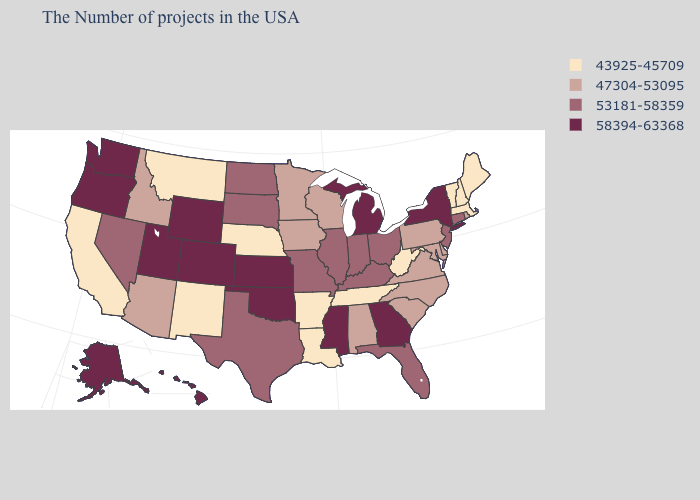Which states have the highest value in the USA?
Give a very brief answer. New York, Georgia, Michigan, Mississippi, Kansas, Oklahoma, Wyoming, Colorado, Utah, Washington, Oregon, Alaska, Hawaii. Which states have the highest value in the USA?
Give a very brief answer. New York, Georgia, Michigan, Mississippi, Kansas, Oklahoma, Wyoming, Colorado, Utah, Washington, Oregon, Alaska, Hawaii. Which states hav the highest value in the MidWest?
Answer briefly. Michigan, Kansas. Which states have the highest value in the USA?
Concise answer only. New York, Georgia, Michigan, Mississippi, Kansas, Oklahoma, Wyoming, Colorado, Utah, Washington, Oregon, Alaska, Hawaii. What is the lowest value in the USA?
Write a very short answer. 43925-45709. Does Washington have the highest value in the USA?
Short answer required. Yes. What is the value of Missouri?
Short answer required. 53181-58359. Does Louisiana have the lowest value in the USA?
Quick response, please. Yes. Name the states that have a value in the range 58394-63368?
Answer briefly. New York, Georgia, Michigan, Mississippi, Kansas, Oklahoma, Wyoming, Colorado, Utah, Washington, Oregon, Alaska, Hawaii. Name the states that have a value in the range 53181-58359?
Write a very short answer. Connecticut, New Jersey, Ohio, Florida, Kentucky, Indiana, Illinois, Missouri, Texas, South Dakota, North Dakota, Nevada. Name the states that have a value in the range 58394-63368?
Concise answer only. New York, Georgia, Michigan, Mississippi, Kansas, Oklahoma, Wyoming, Colorado, Utah, Washington, Oregon, Alaska, Hawaii. Name the states that have a value in the range 58394-63368?
Keep it brief. New York, Georgia, Michigan, Mississippi, Kansas, Oklahoma, Wyoming, Colorado, Utah, Washington, Oregon, Alaska, Hawaii. Which states have the highest value in the USA?
Write a very short answer. New York, Georgia, Michigan, Mississippi, Kansas, Oklahoma, Wyoming, Colorado, Utah, Washington, Oregon, Alaska, Hawaii. Does Kentucky have a higher value than Alabama?
Write a very short answer. Yes. Does Pennsylvania have a lower value than North Dakota?
Answer briefly. Yes. 